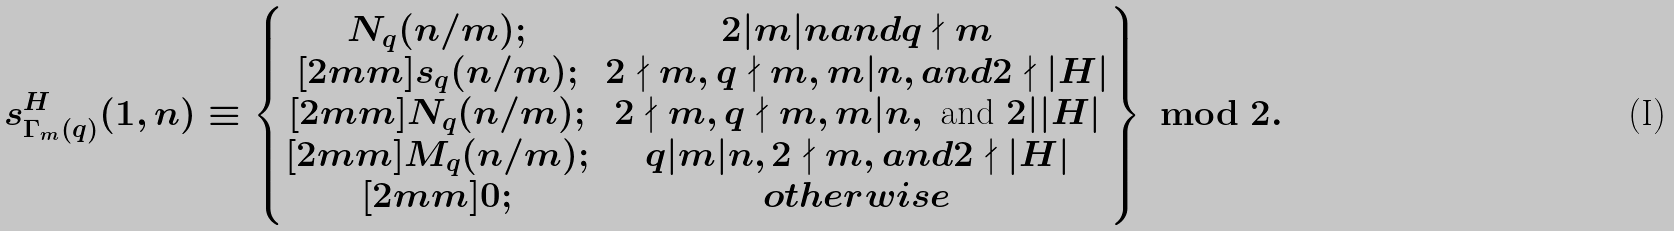Convert formula to latex. <formula><loc_0><loc_0><loc_500><loc_500>s _ { \Gamma _ { m } ( q ) } ^ { H } ( 1 , n ) \equiv \left \{ \begin{matrix} N _ { q } ( n / m ) ; & 2 | m | n a n d q \nmid m \\ [ 2 m m ] s _ { q } ( n / m ) ; & 2 \nmid m , q \nmid m , m | n , a n d 2 \nmid | H | \\ [ 2 m m ] N _ { q } ( n / m ) ; & 2 \nmid m , q \nmid m , m | n , \text { and } 2 | | H | \\ [ 2 m m ] M _ { q } ( n / m ) ; & q | m | n , 2 \nmid m , a n d 2 \nmid | H | \\ [ 2 m m ] 0 ; & o t h e r w i s e \end{matrix} \right \} \, \bmod { 2 } .</formula> 